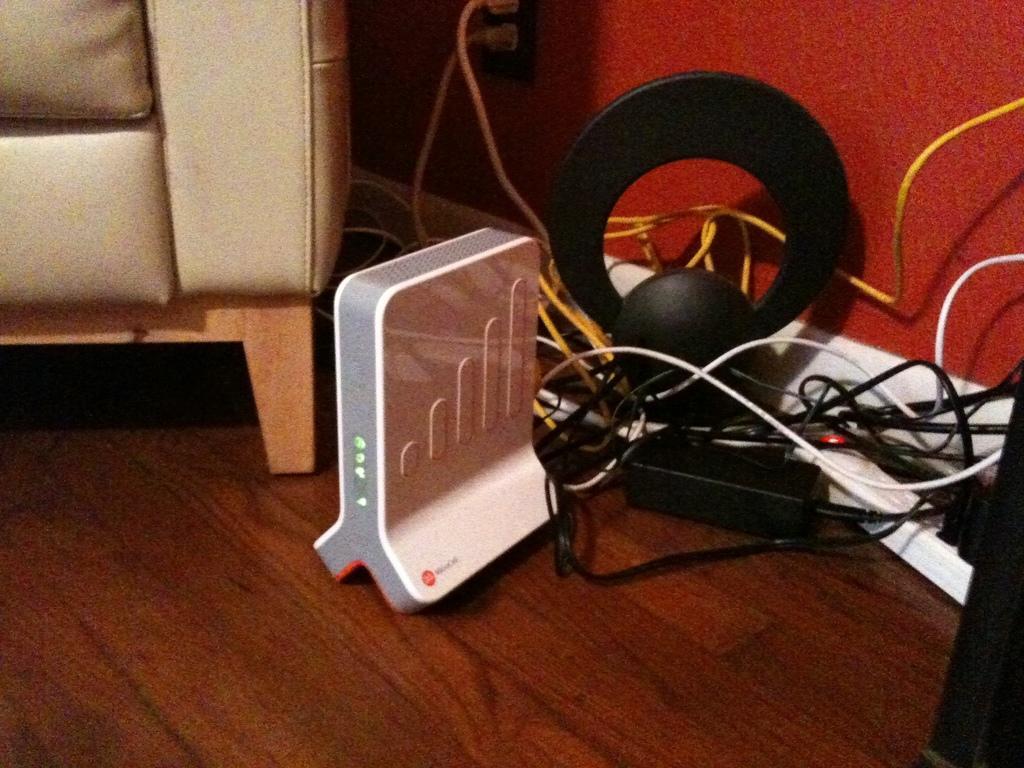Could you give a brief overview of what you see in this image? In this image there is a sofa truncated towards the left of the image, there is a device on the floor, there are wires truncated, there is a red color wall, towards the right of the image there is object truncated, there is a socket and plug. 